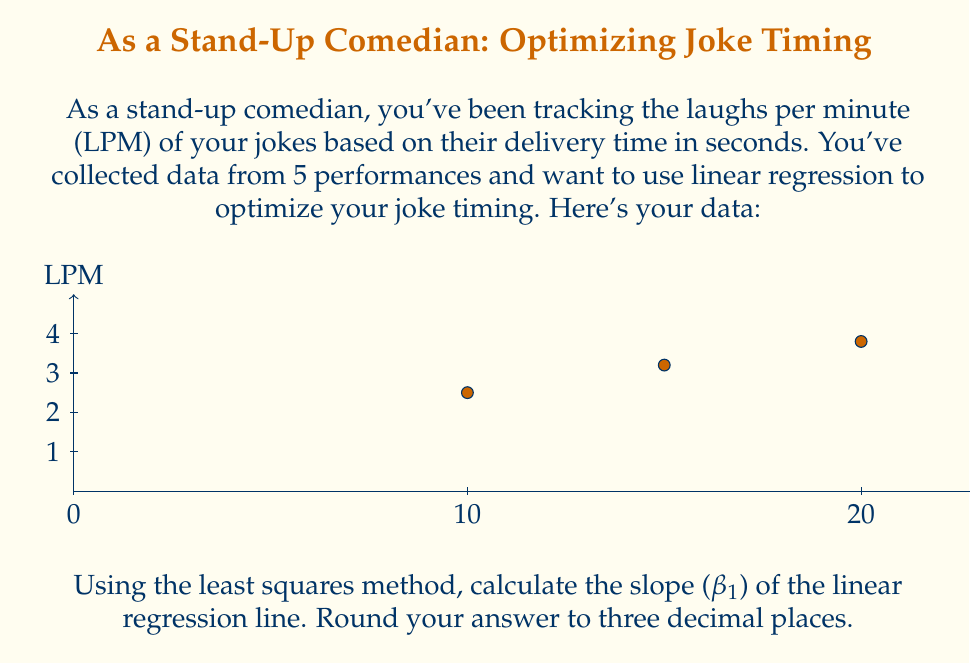Show me your answer to this math problem. Let's approach this step-by-step using the least squares method for linear regression.

1) First, we need to calculate the means of x (delivery time) and y (LPM):
   $\bar{x} = \frac{10 + 15 + 20 + 25 + 30}{5} = 20$
   $\bar{y} = \frac{2.5 + 3.2 + 3.8 + 4.1 + 4.5}{5} = 3.62$

2) Now, we'll calculate the necessary sums for the slope formula:
   $\sum (x_i - \bar{x})(y_i - \bar{y})$ and $\sum (x_i - \bar{x})^2$

3) Let's compute these values:
   $(10-20)(2.5-3.62) + (15-20)(3.2-3.62) + (20-20)(3.8-3.62) + (25-20)(4.1-3.62) + (30-20)(4.5-3.62)$
   $= 11.2 + 2.1 + 0 + 2.4 + 8.8 = 24.5$

   $(10-20)^2 + (15-20)^2 + (20-20)^2 + (25-20)^2 + (30-20)^2$
   $= 100 + 25 + 0 + 25 + 100 = 250$

4) The slope (β₁) is given by the formula:
   $$\beta_1 = \frac{\sum (x_i - \bar{x})(y_i - \bar{y})}{\sum (x_i - \bar{x})^2}$$

5) Plugging in our calculated values:
   $$\beta_1 = \frac{24.5}{250} = 0.098$$

6) Rounding to three decimal places:
   $\beta_1 \approx 0.098$
Answer: 0.098 